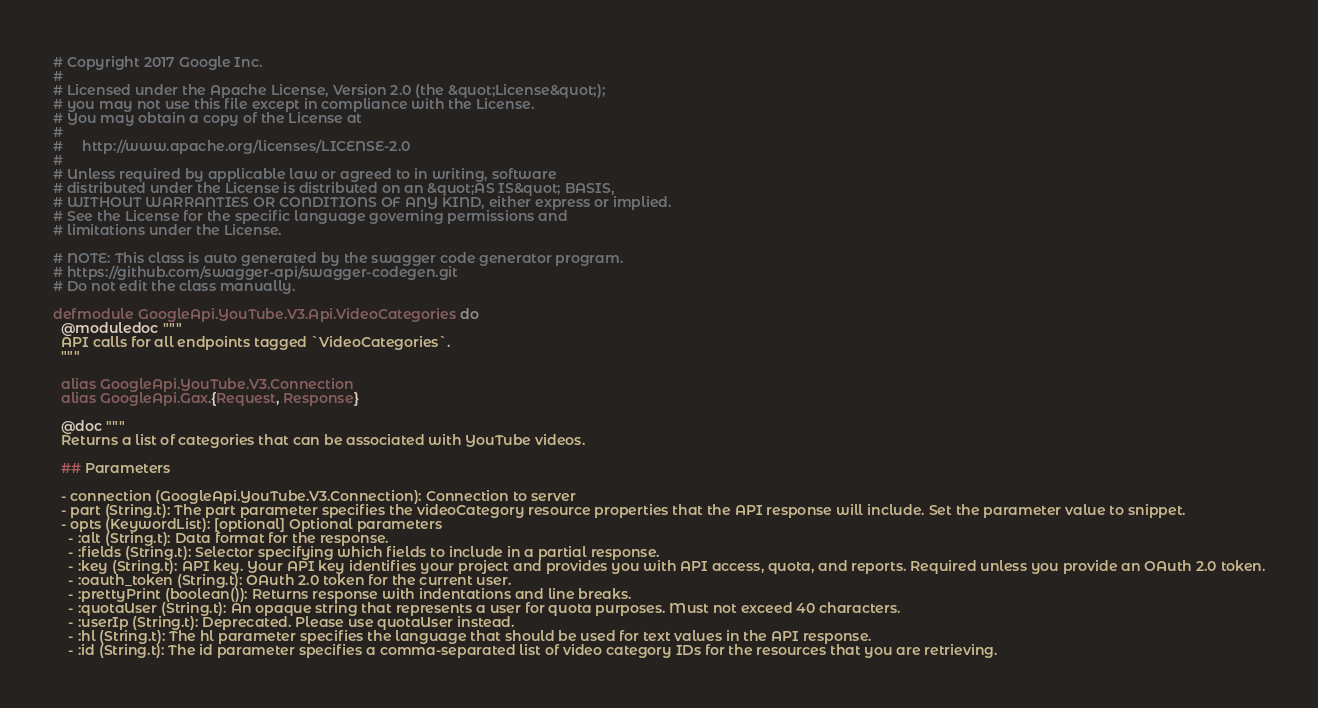Convert code to text. <code><loc_0><loc_0><loc_500><loc_500><_Elixir_># Copyright 2017 Google Inc.
#
# Licensed under the Apache License, Version 2.0 (the &quot;License&quot;);
# you may not use this file except in compliance with the License.
# You may obtain a copy of the License at
#
#     http://www.apache.org/licenses/LICENSE-2.0
#
# Unless required by applicable law or agreed to in writing, software
# distributed under the License is distributed on an &quot;AS IS&quot; BASIS,
# WITHOUT WARRANTIES OR CONDITIONS OF ANY KIND, either express or implied.
# See the License for the specific language governing permissions and
# limitations under the License.

# NOTE: This class is auto generated by the swagger code generator program.
# https://github.com/swagger-api/swagger-codegen.git
# Do not edit the class manually.

defmodule GoogleApi.YouTube.V3.Api.VideoCategories do
  @moduledoc """
  API calls for all endpoints tagged `VideoCategories`.
  """

  alias GoogleApi.YouTube.V3.Connection
  alias GoogleApi.Gax.{Request, Response}

  @doc """
  Returns a list of categories that can be associated with YouTube videos.

  ## Parameters

  - connection (GoogleApi.YouTube.V3.Connection): Connection to server
  - part (String.t): The part parameter specifies the videoCategory resource properties that the API response will include. Set the parameter value to snippet.
  - opts (KeywordList): [optional] Optional parameters
    - :alt (String.t): Data format for the response.
    - :fields (String.t): Selector specifying which fields to include in a partial response.
    - :key (String.t): API key. Your API key identifies your project and provides you with API access, quota, and reports. Required unless you provide an OAuth 2.0 token.
    - :oauth_token (String.t): OAuth 2.0 token for the current user.
    - :prettyPrint (boolean()): Returns response with indentations and line breaks.
    - :quotaUser (String.t): An opaque string that represents a user for quota purposes. Must not exceed 40 characters.
    - :userIp (String.t): Deprecated. Please use quotaUser instead.
    - :hl (String.t): The hl parameter specifies the language that should be used for text values in the API response.
    - :id (String.t): The id parameter specifies a comma-separated list of video category IDs for the resources that you are retrieving.</code> 